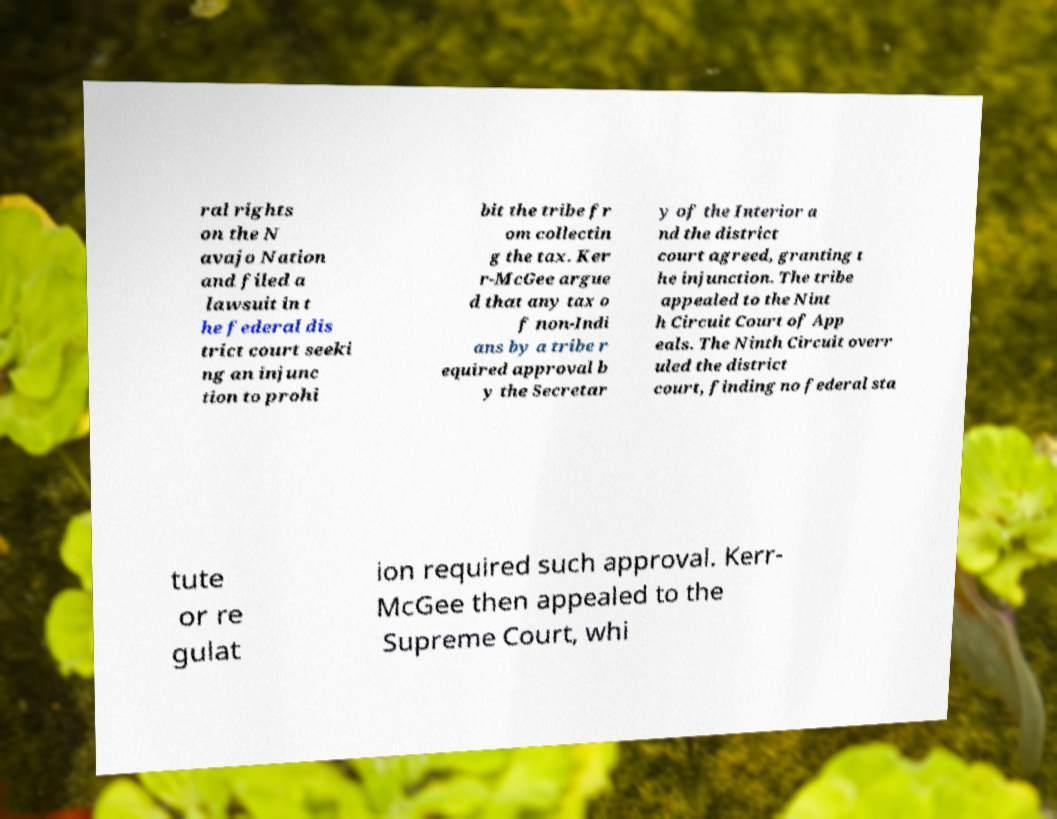I need the written content from this picture converted into text. Can you do that? ral rights on the N avajo Nation and filed a lawsuit in t he federal dis trict court seeki ng an injunc tion to prohi bit the tribe fr om collectin g the tax. Ker r-McGee argue d that any tax o f non-Indi ans by a tribe r equired approval b y the Secretar y of the Interior a nd the district court agreed, granting t he injunction. The tribe appealed to the Nint h Circuit Court of App eals. The Ninth Circuit overr uled the district court, finding no federal sta tute or re gulat ion required such approval. Kerr- McGee then appealed to the Supreme Court, whi 